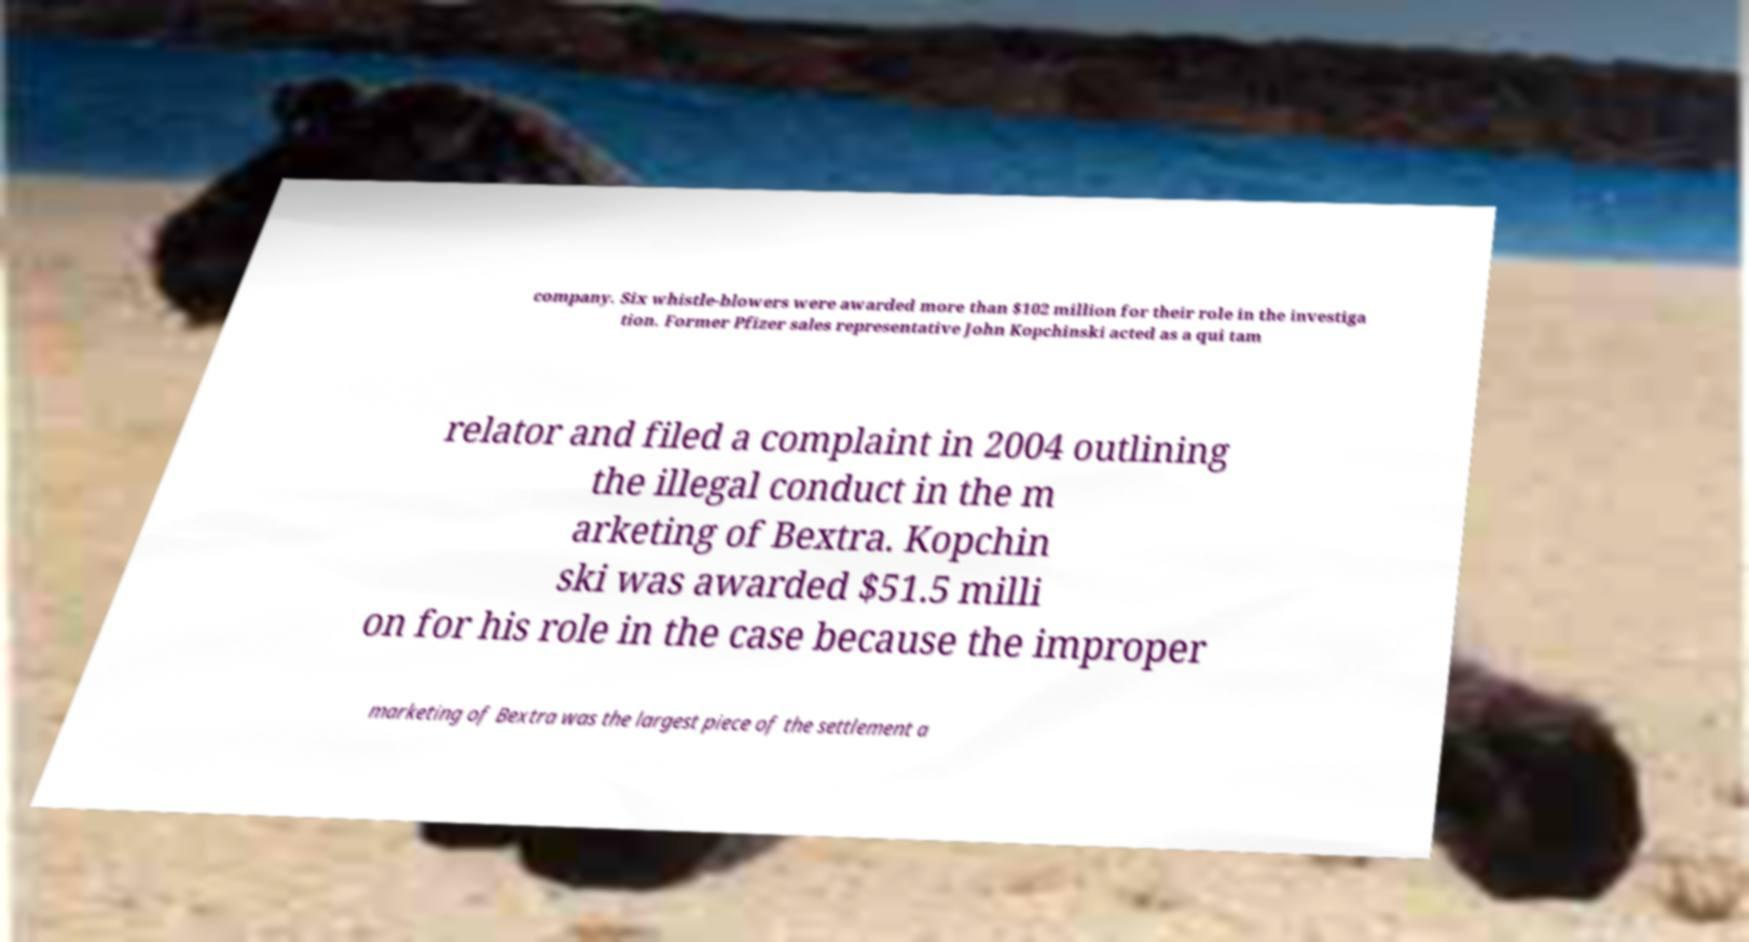Could you assist in decoding the text presented in this image and type it out clearly? company. Six whistle-blowers were awarded more than $102 million for their role in the investiga tion. Former Pfizer sales representative John Kopchinski acted as a qui tam relator and filed a complaint in 2004 outlining the illegal conduct in the m arketing of Bextra. Kopchin ski was awarded $51.5 milli on for his role in the case because the improper marketing of Bextra was the largest piece of the settlement a 